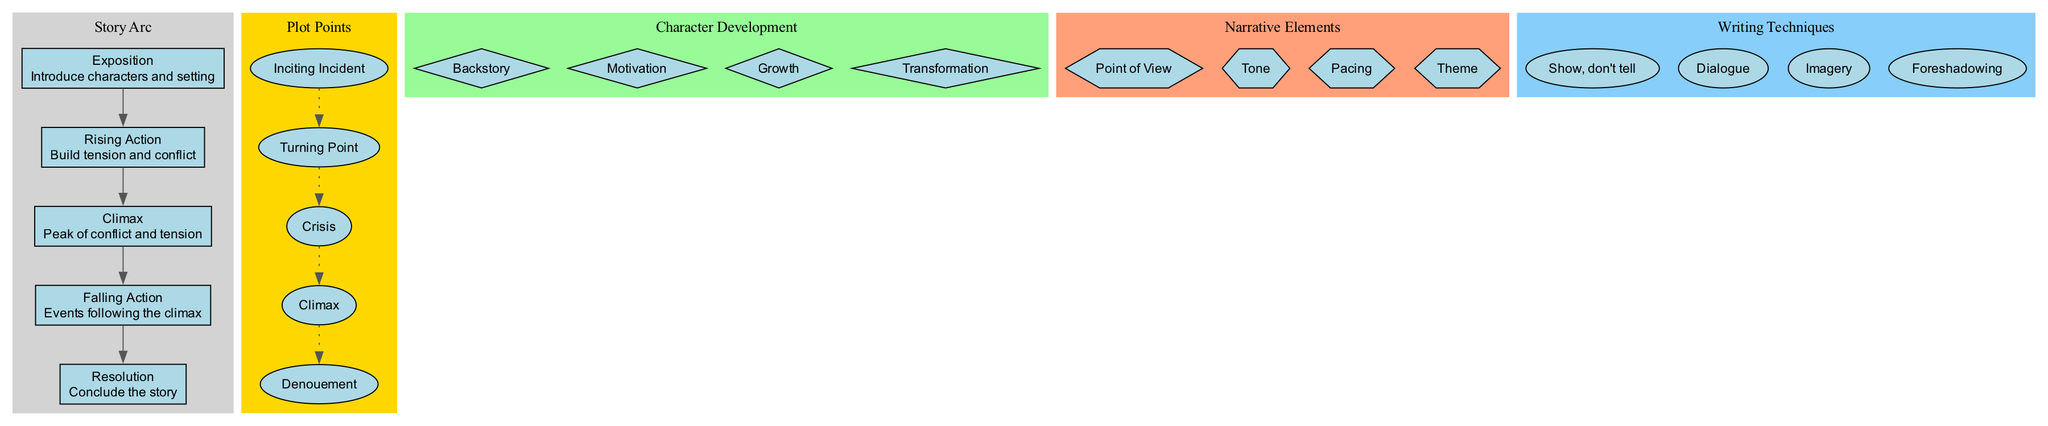What are the main components of a short story? The diagram lists five main components: Exposition, Rising Action, Climax, Falling Action, and Resolution. Each of these components is shown in sequence, forming the story arc.
Answer: Exposition, Rising Action, Climax, Falling Action, Resolution How many plot points are displayed? By counting the nodes in the plot points section, we determine there are five distinct plot points: Inciting Incident, Turning Point, Crisis, Climax, and Denouement.
Answer: 5 What shape represents character development in the diagram? The nodes representing character development aspects are displayed as diamonds. This shape is consistent throughout the character development section.
Answer: Diamond What is the relationship between the Climax and Falling Action? The diagram flows sequentially from the Climax to the Falling Action, indicating that Falling Action occurs directly after the Climax in the structure of a short story.
Answer: Direct Which narrative element is listed as the first in the diagram? The first narrative element listed in the diagram is Point of View, as it appears at the top when reviewing the narrative elements cluster.
Answer: Point of View How many writing techniques are featured in the diagram? The writing techniques section contains four different techniques: Show, don't tell, Dialogue, Imagery, and Foreshadowing, making the total count four.
Answer: 4 What does the Climax signify in the short story structure? The Climax is defined in the diagram as the "Peak of conflict and tension," serving as the moment of greatest intensity in the narrative arc.
Answer: Peak of conflict and tension Which component comes after Rising Action? The diagram clearly indicates that Falling Action follows immediately after Rising Action, maintaining the flow of the story arc.
Answer: Falling Action What color is the cluster for narrative elements? The narrative elements cluster is filled with a light orange color, as indicated in the diagram’s color coding for different sections.
Answer: Light orange 